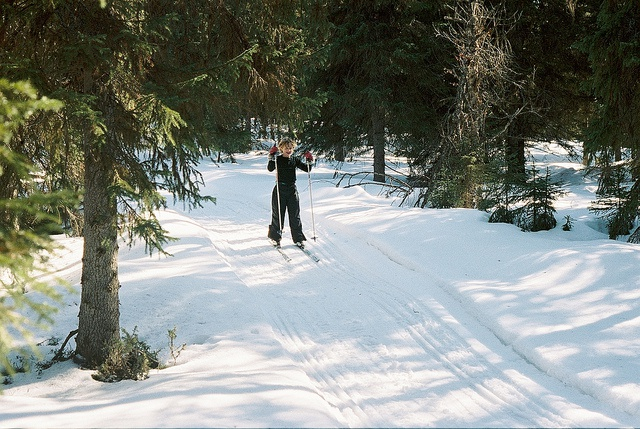Describe the objects in this image and their specific colors. I can see people in black, lightgray, gray, and darkgray tones and skis in black, darkgray, lightgray, and gray tones in this image. 